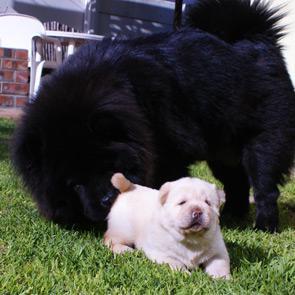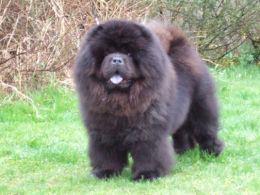The first image is the image on the left, the second image is the image on the right. For the images displayed, is the sentence "The left image contains one black chow dog." factually correct? Answer yes or no. Yes. The first image is the image on the left, the second image is the image on the right. Given the left and right images, does the statement "The right image contains one adult red-orange chow standing in profile turned leftward, and the left image includes a fluffy young chow facing forward." hold true? Answer yes or no. No. 